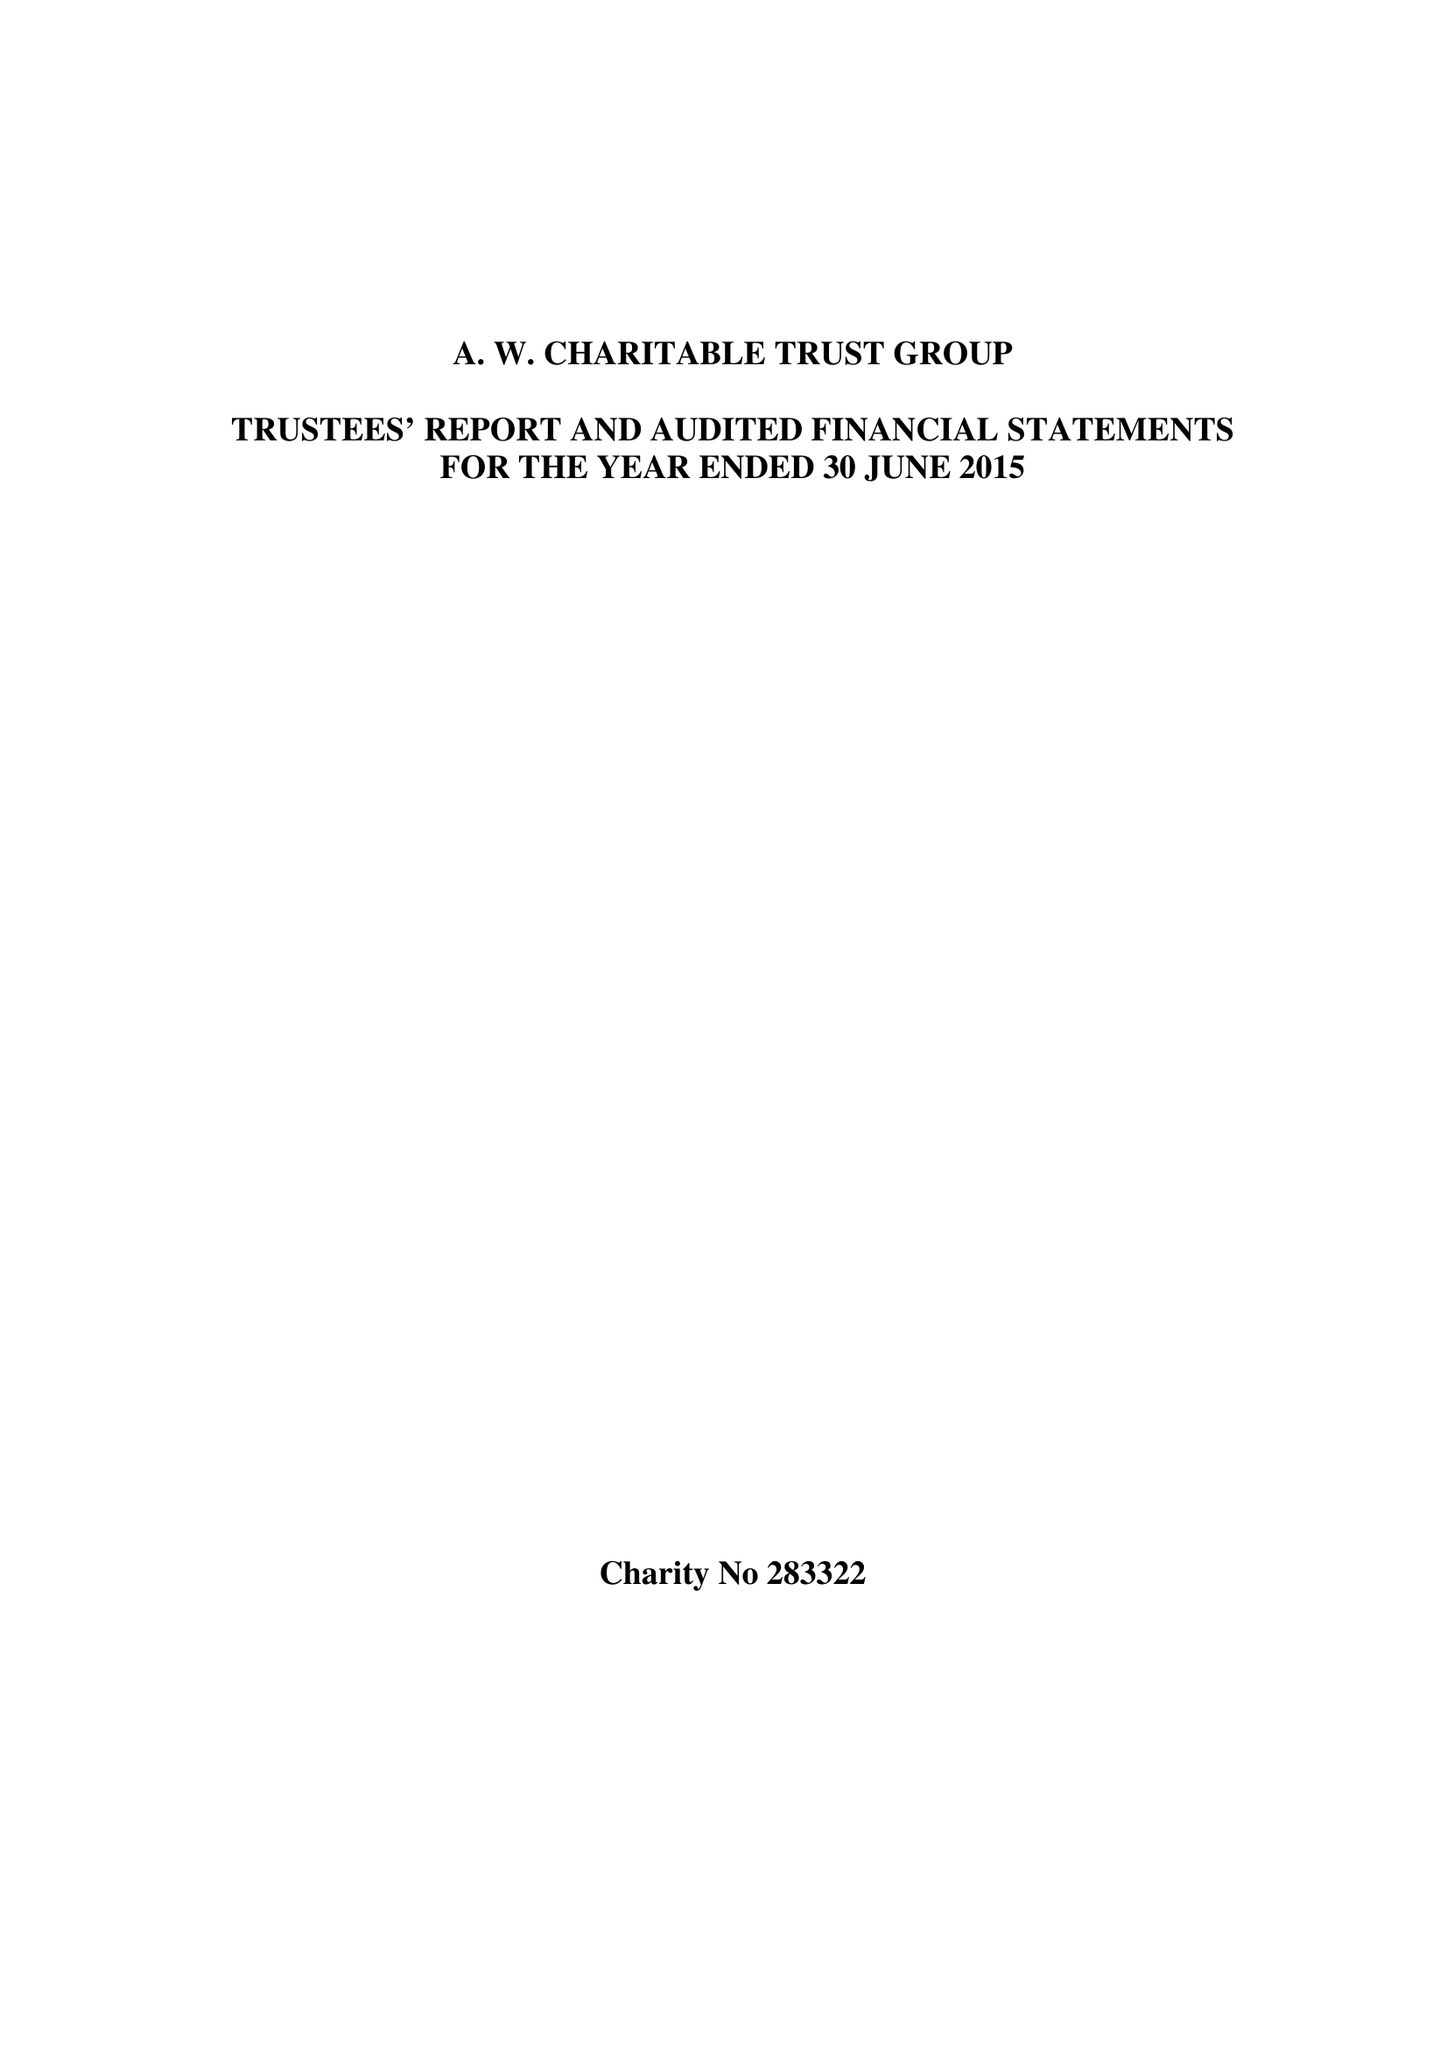What is the value for the charity_name?
Answer the question using a single word or phrase. A W Charitable Trust 